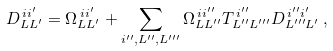Convert formula to latex. <formula><loc_0><loc_0><loc_500><loc_500>D _ { L L ^ { \prime } } ^ { \, i i ^ { \prime } } = \Omega _ { L L ^ { \prime } } ^ { \, i i ^ { \prime } } + \sum _ { i ^ { \prime \prime } , L ^ { \prime \prime } , L ^ { \prime \prime \prime } } \Omega _ { L L ^ { \prime \prime } } ^ { \, i i ^ { \prime \prime } } T _ { L ^ { \prime \prime } L ^ { \prime \prime \prime } } ^ { \, i ^ { \prime \prime } } D _ { L ^ { \prime \prime \prime } L ^ { \prime } } ^ { \, i ^ { \prime \prime } i ^ { \prime } } \, ,</formula> 